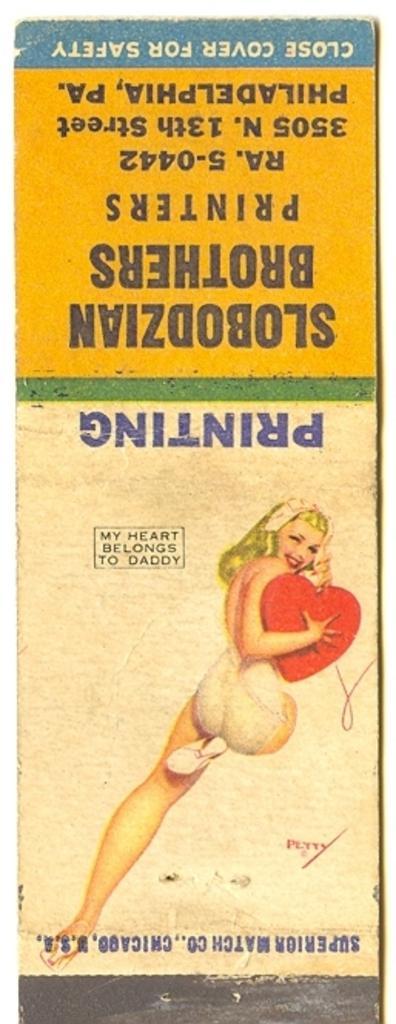Could you give a brief overview of what you see in this image? This is a picture of the poster. At the bottom, we see the image of the woman who is smiling. In the background, it is white in color. At the top, it is in blue, yellow and white color with some text written on it. 